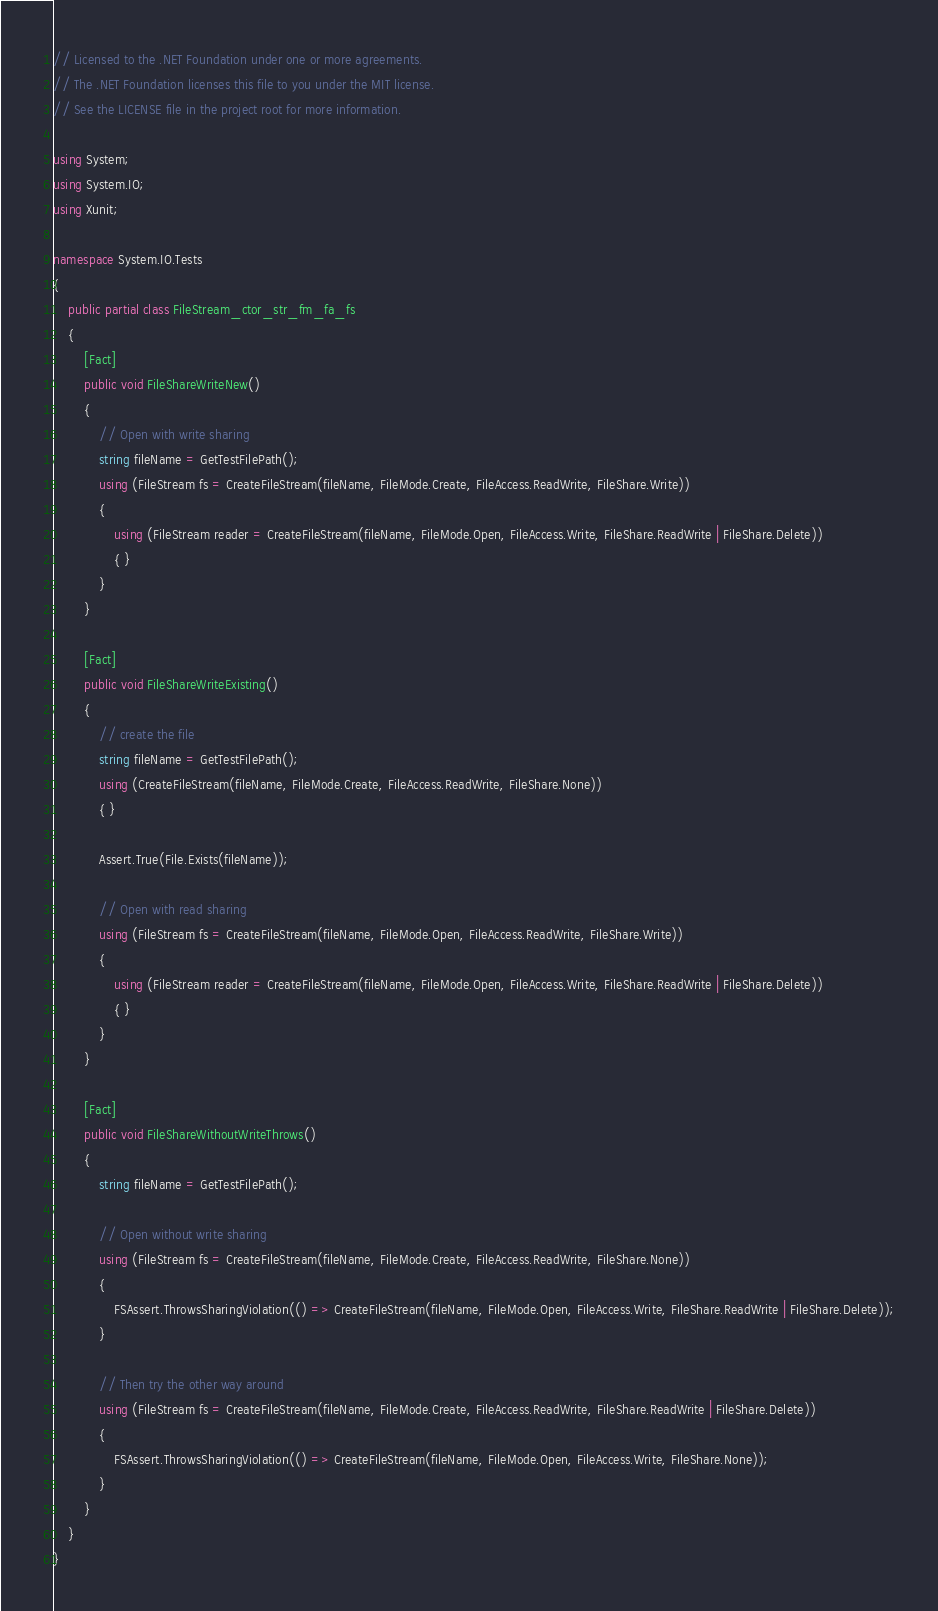<code> <loc_0><loc_0><loc_500><loc_500><_C#_>// Licensed to the .NET Foundation under one or more agreements.
// The .NET Foundation licenses this file to you under the MIT license.
// See the LICENSE file in the project root for more information.

using System;
using System.IO;
using Xunit;

namespace System.IO.Tests
{
    public partial class FileStream_ctor_str_fm_fa_fs
    {
        [Fact]
        public void FileShareWriteNew()
        {
            // Open with write sharing
            string fileName = GetTestFilePath();
            using (FileStream fs = CreateFileStream(fileName, FileMode.Create, FileAccess.ReadWrite, FileShare.Write))
            {
                using (FileStream reader = CreateFileStream(fileName, FileMode.Open, FileAccess.Write, FileShare.ReadWrite | FileShare.Delete))
                { }
            }
        }

        [Fact]
        public void FileShareWriteExisting()
        {
            // create the file
            string fileName = GetTestFilePath();
            using (CreateFileStream(fileName, FileMode.Create, FileAccess.ReadWrite, FileShare.None))
            { }

            Assert.True(File.Exists(fileName));

            // Open with read sharing
            using (FileStream fs = CreateFileStream(fileName, FileMode.Open, FileAccess.ReadWrite, FileShare.Write))
            {
                using (FileStream reader = CreateFileStream(fileName, FileMode.Open, FileAccess.Write, FileShare.ReadWrite | FileShare.Delete))
                { }
            }
        }

        [Fact]
        public void FileShareWithoutWriteThrows()
        {
            string fileName = GetTestFilePath();

            // Open without write sharing
            using (FileStream fs = CreateFileStream(fileName, FileMode.Create, FileAccess.ReadWrite, FileShare.None))
            {
                FSAssert.ThrowsSharingViolation(() => CreateFileStream(fileName, FileMode.Open, FileAccess.Write, FileShare.ReadWrite | FileShare.Delete));
            }

            // Then try the other way around
            using (FileStream fs = CreateFileStream(fileName, FileMode.Create, FileAccess.ReadWrite, FileShare.ReadWrite | FileShare.Delete))
            {
                FSAssert.ThrowsSharingViolation(() => CreateFileStream(fileName, FileMode.Open, FileAccess.Write, FileShare.None));
            }
        }
    }
}
</code> 